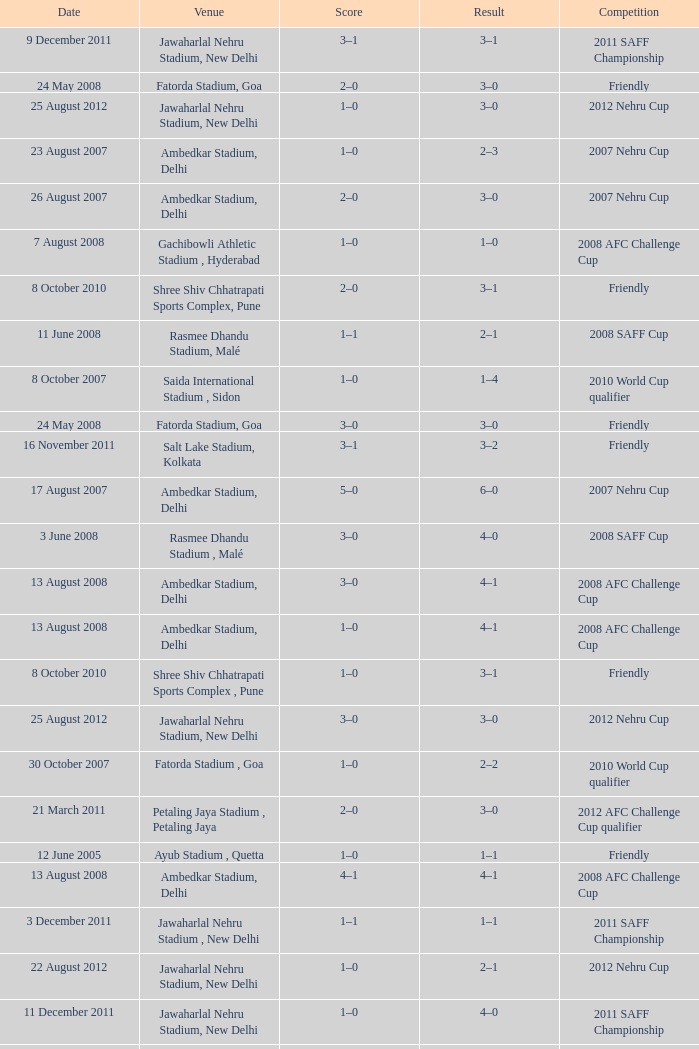Tell me the score on 22 august 2012 1–0. Could you help me parse every detail presented in this table? {'header': ['Date', 'Venue', 'Score', 'Result', 'Competition'], 'rows': [['9 December 2011', 'Jawaharlal Nehru Stadium, New Delhi', '3–1', '3–1', '2011 SAFF Championship'], ['24 May 2008', 'Fatorda Stadium, Goa', '2–0', '3–0', 'Friendly'], ['25 August 2012', 'Jawaharlal Nehru Stadium, New Delhi', '1–0', '3–0', '2012 Nehru Cup'], ['23 August 2007', 'Ambedkar Stadium, Delhi', '1–0', '2–3', '2007 Nehru Cup'], ['26 August 2007', 'Ambedkar Stadium, Delhi', '2–0', '3–0', '2007 Nehru Cup'], ['7 August 2008', 'Gachibowli Athletic Stadium , Hyderabad', '1–0', '1–0', '2008 AFC Challenge Cup'], ['8 October 2010', 'Shree Shiv Chhatrapati Sports Complex, Pune', '2–0', '3–1', 'Friendly'], ['11 June 2008', 'Rasmee Dhandu Stadium, Malé', '1–1', '2–1', '2008 SAFF Cup'], ['8 October 2007', 'Saida International Stadium , Sidon', '1–0', '1–4', '2010 World Cup qualifier'], ['24 May 2008', 'Fatorda Stadium, Goa', '3–0', '3–0', 'Friendly'], ['16 November 2011', 'Salt Lake Stadium, Kolkata', '3–1', '3–2', 'Friendly'], ['17 August 2007', 'Ambedkar Stadium, Delhi', '5–0', '6–0', '2007 Nehru Cup'], ['3 June 2008', 'Rasmee Dhandu Stadium , Malé', '3–0', '4–0', '2008 SAFF Cup'], ['13 August 2008', 'Ambedkar Stadium, Delhi', '3–0', '4–1', '2008 AFC Challenge Cup'], ['13 August 2008', 'Ambedkar Stadium, Delhi', '1–0', '4–1', '2008 AFC Challenge Cup'], ['8 October 2010', 'Shree Shiv Chhatrapati Sports Complex , Pune', '1–0', '3–1', 'Friendly'], ['25 August 2012', 'Jawaharlal Nehru Stadium, New Delhi', '3–0', '3–0', '2012 Nehru Cup'], ['30 October 2007', 'Fatorda Stadium , Goa', '1–0', '2–2', '2010 World Cup qualifier'], ['21 March 2011', 'Petaling Jaya Stadium , Petaling Jaya', '2–0', '3–0', '2012 AFC Challenge Cup qualifier'], ['12 June 2005', 'Ayub Stadium , Quetta', '1–0', '1–1', 'Friendly'], ['13 August 2008', 'Ambedkar Stadium, Delhi', '4–1', '4–1', '2008 AFC Challenge Cup'], ['3 December 2011', 'Jawaharlal Nehru Stadium , New Delhi', '1–1', '1–1', '2011 SAFF Championship'], ['22 August 2012', 'Jawaharlal Nehru Stadium, New Delhi', '1–0', '2–1', '2012 Nehru Cup'], ['11 December 2011', 'Jawaharlal Nehru Stadium, New Delhi', '1–0', '4–0', '2011 SAFF Championship'], ['23 August 2009', 'Ambedkar Stadium, Delhi', '2–0', '2–1', '2009 Nehru Cup'], ['10 July 2011', 'Rasmee Dhandu Stadium , Malé', '1–0', '1–1', 'Friendly'], ['17 August 2007', 'Ambedkar Stadium , Delhi', '4–0', '6–0', '2007 Nehru Cup'], ['4 March 2013', 'Thuwunna Stadium, Yangon', '4–0', '4–0', '2014 AFC Challenge Cup qualifier'], ['4 March 2013', 'Thuwunna Stadium , Yangon', '1–0', '4–0', '2014 AFC Challenge cup qualifier'], ['8 October 2010', 'Shree Shiv Chhatrapati Sports Complex, Pune', '3–1', '3–1', 'Friendly'], ['18 January 2011', 'Al-Gharafa Stadium , Doha', '1–2', '1–4', '2011 Asian Cup'], ['14 January 2011', 'Jassim Bin Hamad Stadium , Doha', '2–4', '2–5', '2011 Asian Cup'], ['16 November 2011', 'Salt Lake Stadium , Kolkata', '1–0', '3–2', 'Friendly'], ['5 December 2011', 'Jawaharlal Nehru Stadium, New Delhi', '4–0', '5–0', '2011 SAFF Championship'], ['7 December 2011', 'Jawaharlal Nehru Stadium, New Delhi', '2–0', '3–0', '2011 SAFF Championship'], ['3 September 2013', 'Halchowk Stadium , Kathmandu', '1–1', '1–1', '2013 SAFF Championship'], ['5 December 2011', 'Jawaharlal Nehru Stadium, New Delhi', '5–0', '5–0', '2011 SAFF Championship'], ['9 December 2011', 'Jawaharlal Nehru Stadium, New Delhi', '2–1', '3–1', '2011 SAFF Championship']]} 